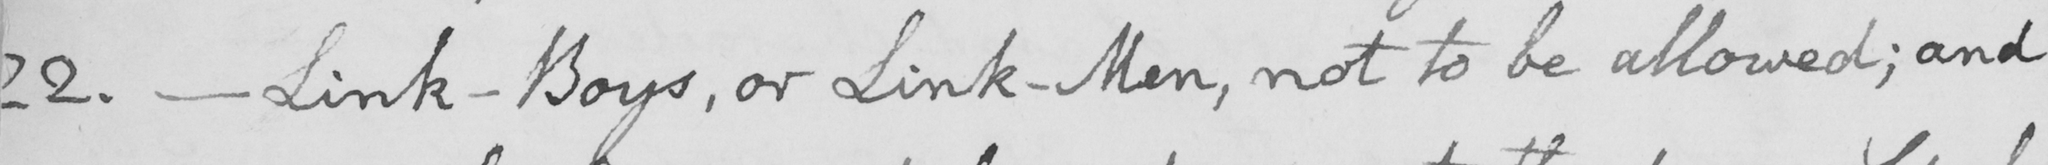What does this handwritten line say? 22 .  _  Link-Boys , or Link-Men , not to be allowed ; and 